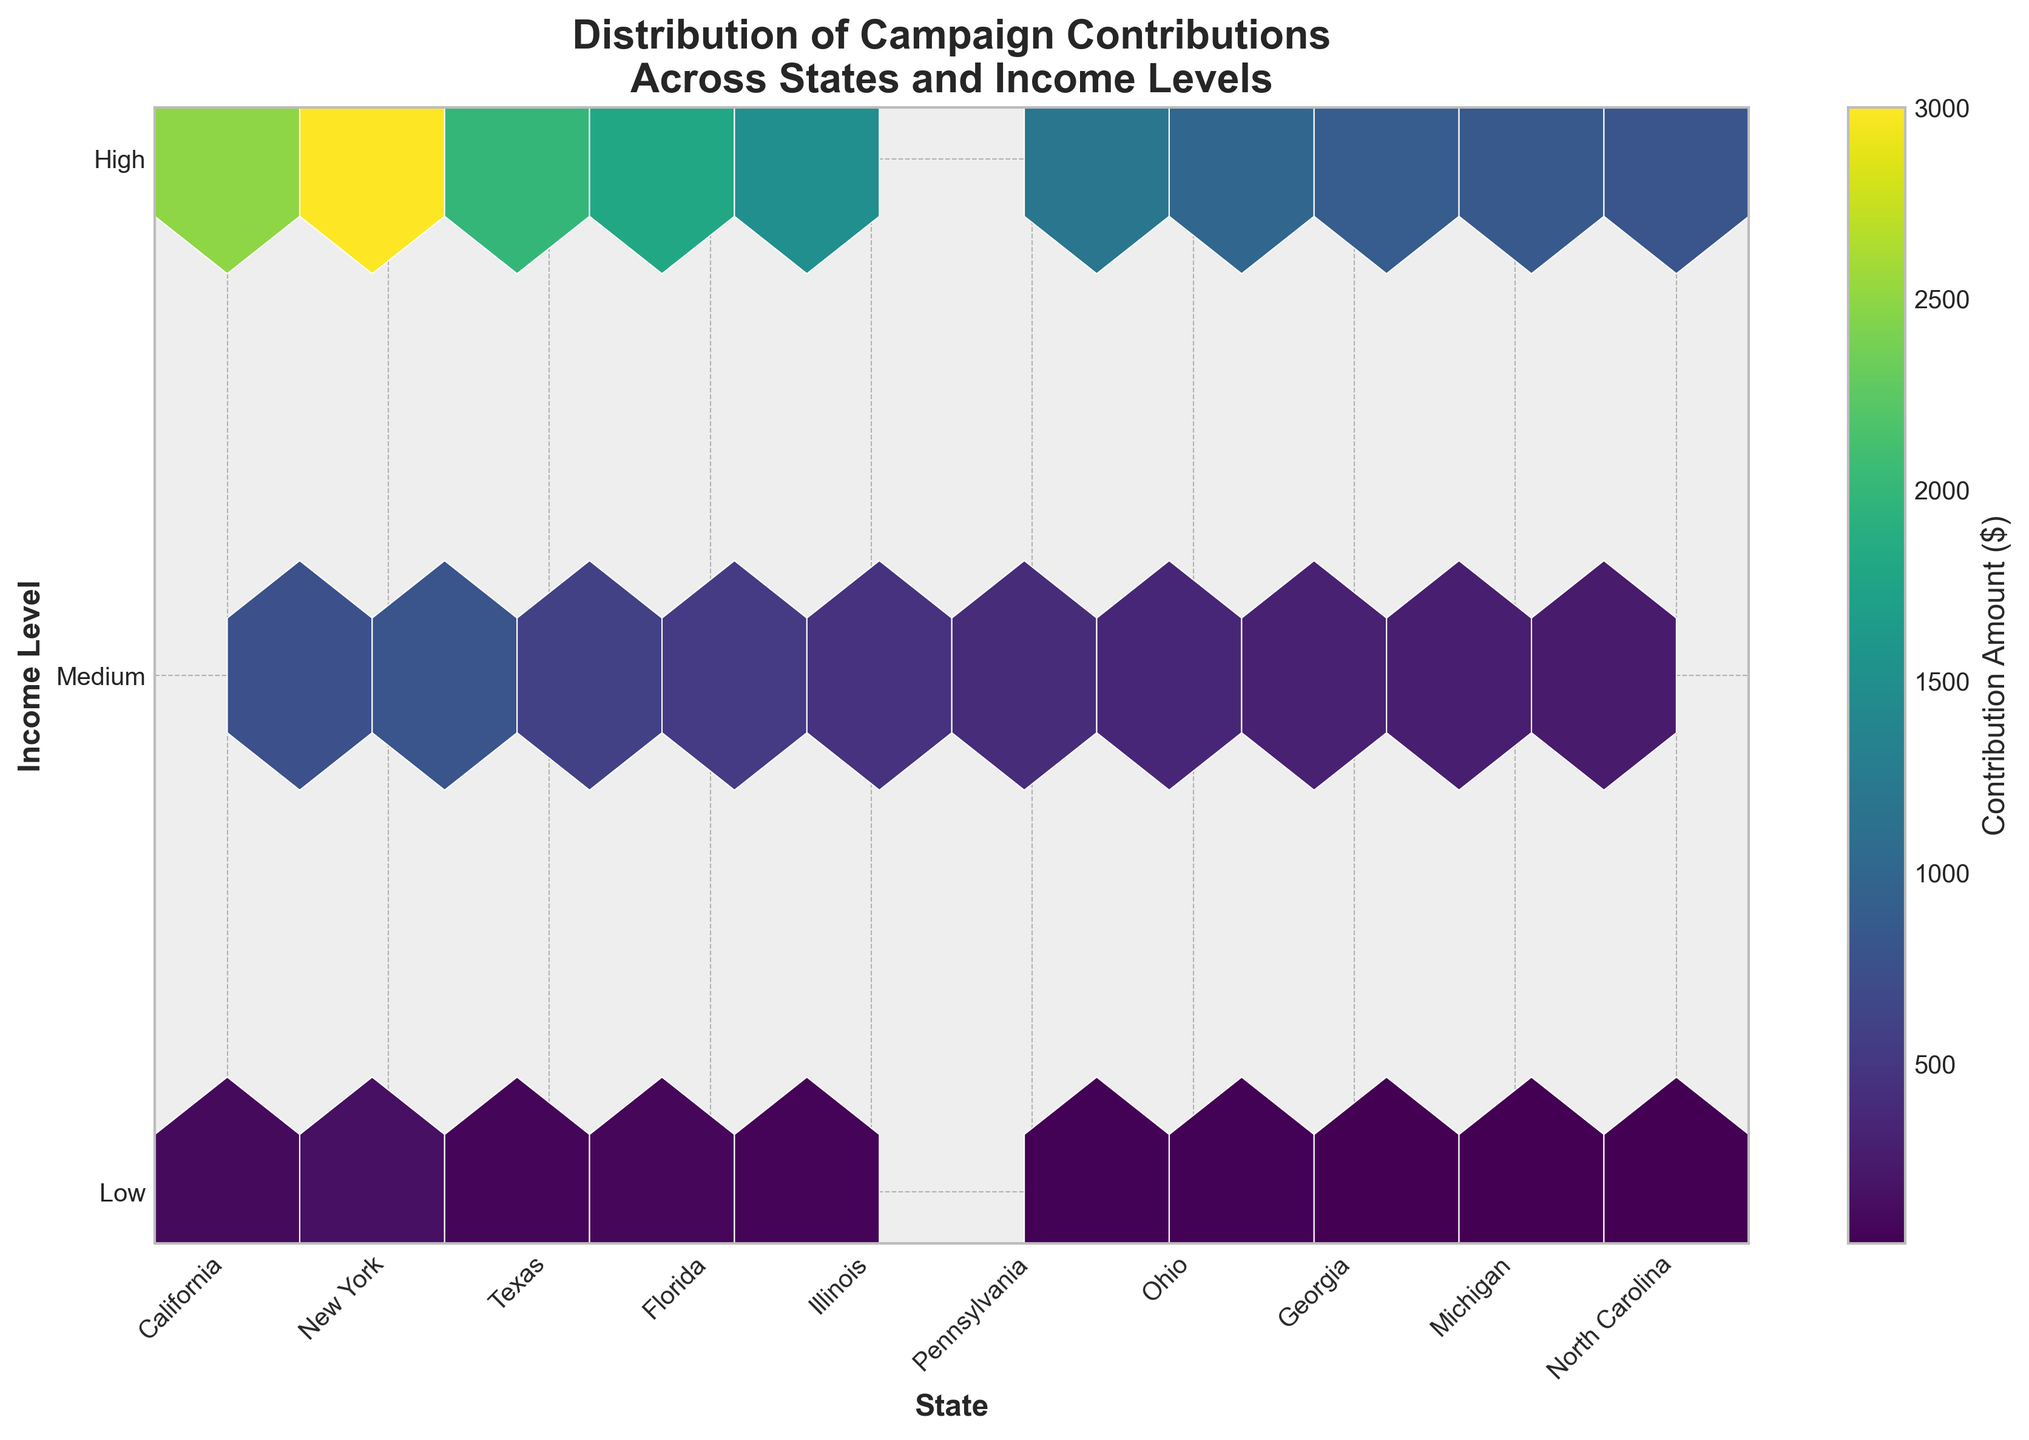What's the title of the plot? The title of the plot is displayed at the top and reads "Distribution of Campaign Contributions Across States and Income Levels".
Answer: "Distribution of Campaign Contributions Across States and Income Levels" Which state has the highest contribution from the high-income level? In the hexbin plot, the darkest hexagon representing the highest contribution amount is located at the intersection of New York (x-axis) and High (y-axis).
Answer: New York How many states are represented in the plot? The x-axis ticks show the individual states, starting from California on the left to North Carolina on the right. By counting these ticks, we see that there are 10 states.
Answer: 10 What is the color representing the highest contribution amount? The color bar on the right-hand side of the plot shows the color gradient. The darkest color at the top of the color bar represents the highest contribution amount.
Answer: Darkest color (deep viridis) Which income level in California contributes the least amount? Looking at the hexagons for California on the x-axis, the lightest shaded hexagon is at the Low income level on the y-axis, indicating the least contribution amount.
Answer: Low Compare contributions between high-income levels of California and Texas. Which is higher? The hexagons for the high-income levels of California and Texas show respective contributions, with the one in California being darker than Texas, reflecting a higher contribution.
Answer: California Among the low-income levels, which state has the highest contribution amount? Looking at the low-income level row (y-axis = 1), the darkest hexagon is located at the position for New York on the x-axis, indicating it has the highest contribution among low-income levels.
Answer: New York Which states have medium income levels contributing less than Texas's high-income level? Compare the hexagon for the medium income levels with the hexagon for Texas's high-income level. States like Florida, Illinois, etc., with lighter hexagons in the medium income level row, contribute less than Texas's high income.
Answer: States including Florida, Illinois, Pennsylvania, and others What does the color bar indicate? The color bar on the right-hand side of the plot indicates the contribution amount. Darker colors mean higher contributions and lighter colors indicate lower contributions.
Answer: Contribution Amount Is there any state where all income levels contribute more than Ohio's high-income level? By comparing the hexagon dark shades across states, we see that no single state has all three income levels with darker hexagons than Ohio's high-income level hex (y-axis = 3, contribution = $1000).
Answer: No 